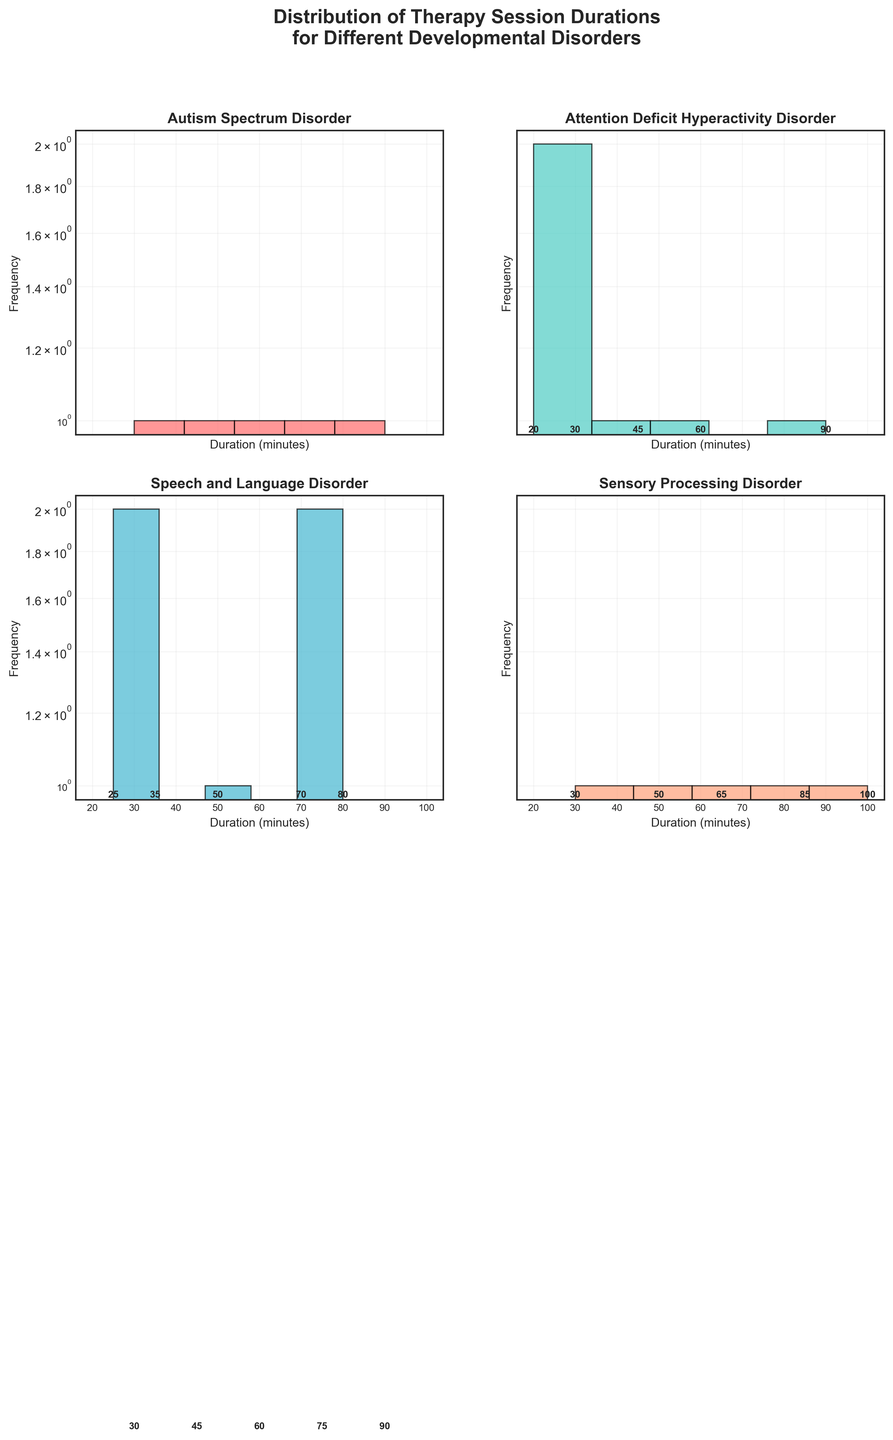what is the title of this figure? The title is displayed at the top of the figure in a bold font. It reads, "Distribution of Therapy Session Durations for Different Developmental Disorders".
Answer: Distribution of Therapy Session Durations for Different Developmental Disorders How many subplots are there in this figure? The figure consists of 2 rows and 2 columns, creating a total of 4 subplots.
Answer: 4 What are the colors used in the plots, and which disorder does each color represent? There are four different colors used: red, turquoise, blue, and light salmon. By looking at the titles on each subplot, we can match the colors with the disorders: Red for Autism Spectrum Disorder, Turquoise for Attention Deficit Hyperactivity Disorder, Blue for Speech and Language Disorder, and Light Salmon for Sensory Processing Disorder.
Answer: Red: Autism Spectrum Disorder, Turquoise: Attention Deficit Hyperactivity Disorder, Blue: Speech and Language Disorder, Light Salmon: Sensory Processing Disorder What is the range of therapy session durations for Autism Spectrum Disorder? The Autism Spectrum Disorder subplot's x-axis shows bins for duration ranges, and the histogram bars show sessions across these ranges. The durations for Autism Spectrum Disorder range from 30 to 90 minutes.
Answer: 30 to 90 minutes Which disorder has the shortest session duration, and what is the duration? By examining all four subplots, the shortest duration appears in the Attention Deficit Hyperactivity Disorder subplot at 20 minutes.
Answer: Attention Deficit Hyperactivity Disorder, 20 minutes Which disorder has the most variations in therapy session durations? It is necessary to look at the spread of the histogram bars in each subplot. The Sensory Processing Disorder subplot shows the widest duration range from 30 to 100 minutes, indicating it has the most variations in therapy session durations.
Answer: Sensory Processing Disorder Compare the frequency of 60-minute sessions between Autism Spectrum Disorder and Attention Deficit Hyperactivity Disorder. The histogram bars at the 60-minute mark for each disorder need to be compared. Both Autism Spectrum Disorder and Attention Deficit Hyperactivity Disorder have a similar frequency for 60-minute sessions, given the height of the bars in each respective subplot.
Answer: Similar frequency What pattern can be observed from the log scale for frequency used in these plots? By examining the y-axis of each subplot, which is in log scale, it is clear that higher frequencies are more compressed, making smaller differences in higher frequencies more noticeable. This pattern helps emphasize variations in lower frequencies.
Answer: Emphasizes variations in lower frequencies What is the highest duration recorded for Speech and Language Disorder? By examining the Speech and Language Disorder subplot, the highest bar extends towards the 80-minute mark, indicating the highest duration recorded.
Answer: 80 minutes 